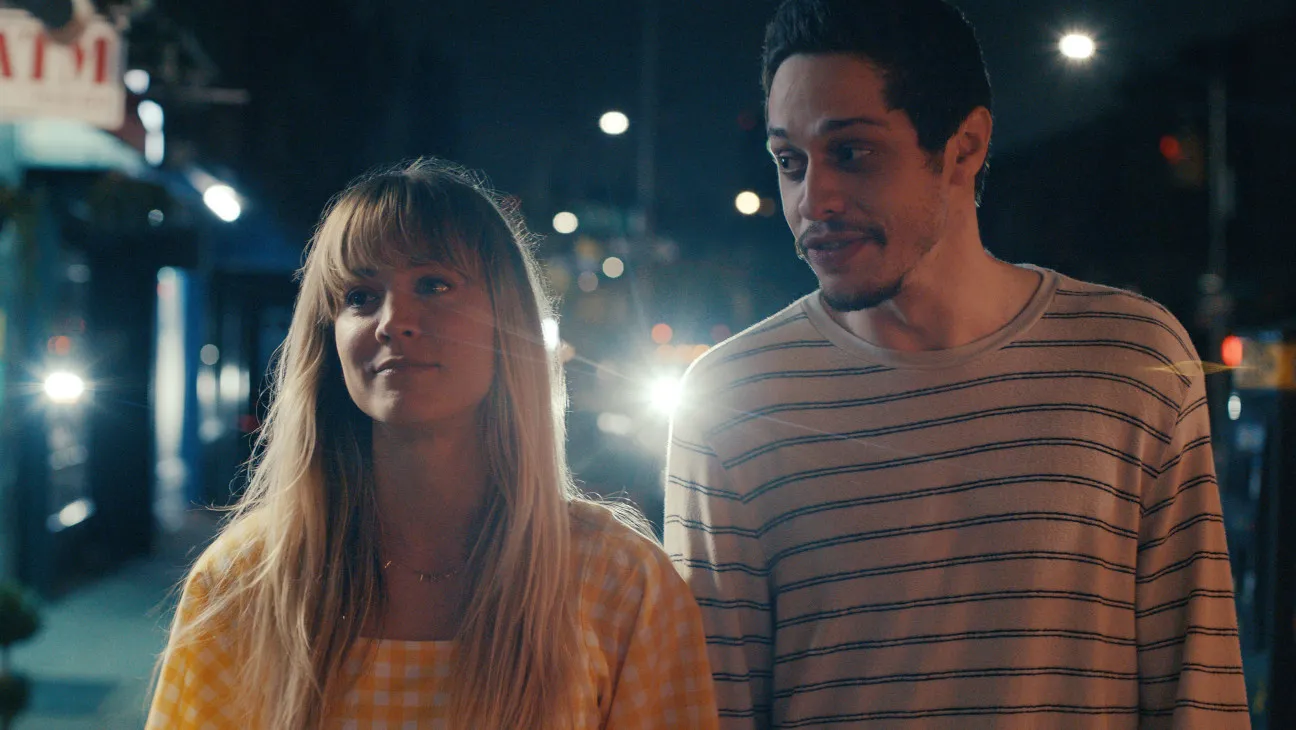Describe the significance of their expressions in this setting. The woman's expression is thoughtful and perhaps a bit wistful, looking upward as if reflecting on something significant or being struck by the surroundings. The man’s gentle smile while looking at the woman suggests warmth and affection. These expressions combined with the urban night setting may imply a moment of personal connection or reflection amidst the surrounding city life, highlighting a contrast between the external environment's energy and their introspective interactions. 